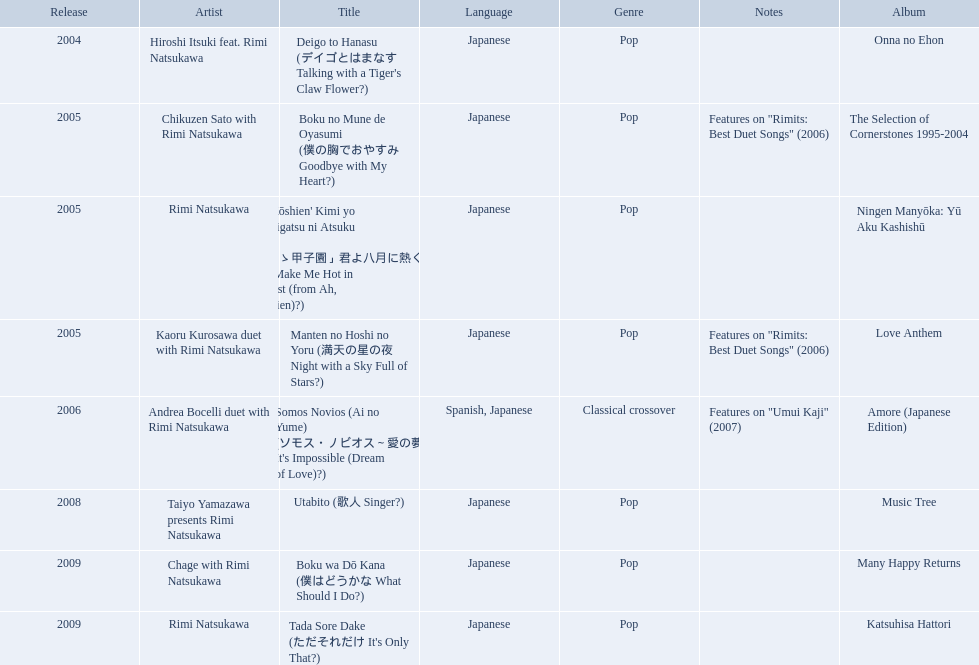What year was onna no ehon released? 2004. What year was music tree released? 2008. Which of the two was not released in 2004? Music Tree. What are the notes for sky full of stars? Features on "Rimits: Best Duet Songs" (2006). What other song features this same note? Boku no Mune de Oyasumi (僕の胸でおやすみ Goodbye with My Heart?). Which title of the rimi natsukawa discography was released in the 2004? Deigo to Hanasu (デイゴとはまなす Talking with a Tiger's Claw Flower?). Which title has notes that features on/rimits. best duet songs\2006 Manten no Hoshi no Yoru (満天の星の夜 Night with a Sky Full of Stars?). Which title share the same notes as night with a sky full of stars? Boku no Mune de Oyasumi (僕の胸でおやすみ Goodbye with My Heart?). 